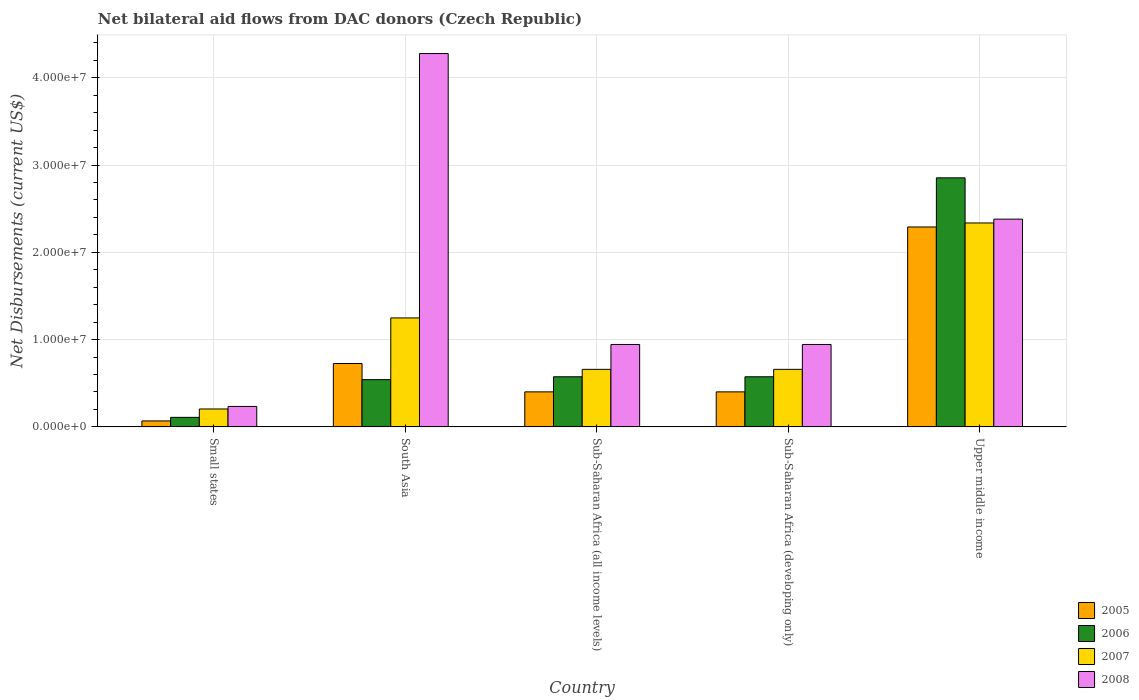How many bars are there on the 4th tick from the left?
Your answer should be compact. 4. How many bars are there on the 1st tick from the right?
Provide a succinct answer. 4. What is the label of the 4th group of bars from the left?
Keep it short and to the point. Sub-Saharan Africa (developing only). What is the net bilateral aid flows in 2006 in Sub-Saharan Africa (all income levels)?
Your answer should be very brief. 5.74e+06. Across all countries, what is the maximum net bilateral aid flows in 2006?
Make the answer very short. 2.85e+07. Across all countries, what is the minimum net bilateral aid flows in 2008?
Provide a short and direct response. 2.34e+06. In which country was the net bilateral aid flows in 2006 maximum?
Make the answer very short. Upper middle income. In which country was the net bilateral aid flows in 2006 minimum?
Your answer should be compact. Small states. What is the total net bilateral aid flows in 2008 in the graph?
Give a very brief answer. 8.78e+07. What is the difference between the net bilateral aid flows in 2007 in South Asia and that in Upper middle income?
Provide a succinct answer. -1.09e+07. What is the difference between the net bilateral aid flows in 2005 in Sub-Saharan Africa (all income levels) and the net bilateral aid flows in 2007 in Small states?
Provide a succinct answer. 1.96e+06. What is the average net bilateral aid flows in 2007 per country?
Offer a very short reply. 1.02e+07. What is the difference between the net bilateral aid flows of/in 2006 and net bilateral aid flows of/in 2008 in South Asia?
Provide a succinct answer. -3.74e+07. In how many countries, is the net bilateral aid flows in 2008 greater than 2000000 US$?
Your answer should be compact. 5. What is the ratio of the net bilateral aid flows in 2006 in Small states to that in Sub-Saharan Africa (developing only)?
Your answer should be compact. 0.19. Is the net bilateral aid flows in 2006 in Small states less than that in Upper middle income?
Offer a terse response. Yes. What is the difference between the highest and the second highest net bilateral aid flows in 2005?
Your answer should be compact. 1.89e+07. What is the difference between the highest and the lowest net bilateral aid flows in 2007?
Keep it short and to the point. 2.13e+07. In how many countries, is the net bilateral aid flows in 2007 greater than the average net bilateral aid flows in 2007 taken over all countries?
Offer a terse response. 2. What does the 4th bar from the left in Small states represents?
Your response must be concise. 2008. Is it the case that in every country, the sum of the net bilateral aid flows in 2006 and net bilateral aid flows in 2005 is greater than the net bilateral aid flows in 2007?
Ensure brevity in your answer.  No. Are all the bars in the graph horizontal?
Your answer should be compact. No. How many countries are there in the graph?
Your response must be concise. 5. Are the values on the major ticks of Y-axis written in scientific E-notation?
Your response must be concise. Yes. Does the graph contain grids?
Provide a short and direct response. Yes. Where does the legend appear in the graph?
Make the answer very short. Bottom right. What is the title of the graph?
Give a very brief answer. Net bilateral aid flows from DAC donors (Czech Republic). Does "1970" appear as one of the legend labels in the graph?
Offer a very short reply. No. What is the label or title of the Y-axis?
Provide a short and direct response. Net Disbursements (current US$). What is the Net Disbursements (current US$) of 2005 in Small states?
Keep it short and to the point. 6.80e+05. What is the Net Disbursements (current US$) of 2006 in Small states?
Provide a succinct answer. 1.09e+06. What is the Net Disbursements (current US$) in 2007 in Small states?
Keep it short and to the point. 2.05e+06. What is the Net Disbursements (current US$) of 2008 in Small states?
Provide a short and direct response. 2.34e+06. What is the Net Disbursements (current US$) of 2005 in South Asia?
Keep it short and to the point. 7.26e+06. What is the Net Disbursements (current US$) of 2006 in South Asia?
Keep it short and to the point. 5.41e+06. What is the Net Disbursements (current US$) in 2007 in South Asia?
Your answer should be very brief. 1.25e+07. What is the Net Disbursements (current US$) in 2008 in South Asia?
Your answer should be very brief. 4.28e+07. What is the Net Disbursements (current US$) of 2005 in Sub-Saharan Africa (all income levels)?
Provide a succinct answer. 4.01e+06. What is the Net Disbursements (current US$) in 2006 in Sub-Saharan Africa (all income levels)?
Make the answer very short. 5.74e+06. What is the Net Disbursements (current US$) of 2007 in Sub-Saharan Africa (all income levels)?
Your response must be concise. 6.59e+06. What is the Net Disbursements (current US$) in 2008 in Sub-Saharan Africa (all income levels)?
Your answer should be very brief. 9.44e+06. What is the Net Disbursements (current US$) of 2005 in Sub-Saharan Africa (developing only)?
Give a very brief answer. 4.01e+06. What is the Net Disbursements (current US$) in 2006 in Sub-Saharan Africa (developing only)?
Make the answer very short. 5.74e+06. What is the Net Disbursements (current US$) in 2007 in Sub-Saharan Africa (developing only)?
Provide a short and direct response. 6.59e+06. What is the Net Disbursements (current US$) in 2008 in Sub-Saharan Africa (developing only)?
Your answer should be compact. 9.44e+06. What is the Net Disbursements (current US$) in 2005 in Upper middle income?
Offer a terse response. 2.29e+07. What is the Net Disbursements (current US$) of 2006 in Upper middle income?
Keep it short and to the point. 2.85e+07. What is the Net Disbursements (current US$) in 2007 in Upper middle income?
Your answer should be very brief. 2.34e+07. What is the Net Disbursements (current US$) in 2008 in Upper middle income?
Your response must be concise. 2.38e+07. Across all countries, what is the maximum Net Disbursements (current US$) of 2005?
Offer a very short reply. 2.29e+07. Across all countries, what is the maximum Net Disbursements (current US$) of 2006?
Your response must be concise. 2.85e+07. Across all countries, what is the maximum Net Disbursements (current US$) of 2007?
Make the answer very short. 2.34e+07. Across all countries, what is the maximum Net Disbursements (current US$) of 2008?
Give a very brief answer. 4.28e+07. Across all countries, what is the minimum Net Disbursements (current US$) of 2005?
Provide a succinct answer. 6.80e+05. Across all countries, what is the minimum Net Disbursements (current US$) in 2006?
Offer a terse response. 1.09e+06. Across all countries, what is the minimum Net Disbursements (current US$) in 2007?
Ensure brevity in your answer.  2.05e+06. Across all countries, what is the minimum Net Disbursements (current US$) of 2008?
Your response must be concise. 2.34e+06. What is the total Net Disbursements (current US$) in 2005 in the graph?
Give a very brief answer. 3.89e+07. What is the total Net Disbursements (current US$) in 2006 in the graph?
Give a very brief answer. 4.65e+07. What is the total Net Disbursements (current US$) of 2007 in the graph?
Make the answer very short. 5.11e+07. What is the total Net Disbursements (current US$) of 2008 in the graph?
Offer a very short reply. 8.78e+07. What is the difference between the Net Disbursements (current US$) in 2005 in Small states and that in South Asia?
Offer a terse response. -6.58e+06. What is the difference between the Net Disbursements (current US$) of 2006 in Small states and that in South Asia?
Offer a terse response. -4.32e+06. What is the difference between the Net Disbursements (current US$) in 2007 in Small states and that in South Asia?
Your answer should be compact. -1.04e+07. What is the difference between the Net Disbursements (current US$) in 2008 in Small states and that in South Asia?
Offer a very short reply. -4.04e+07. What is the difference between the Net Disbursements (current US$) of 2005 in Small states and that in Sub-Saharan Africa (all income levels)?
Your answer should be very brief. -3.33e+06. What is the difference between the Net Disbursements (current US$) of 2006 in Small states and that in Sub-Saharan Africa (all income levels)?
Provide a short and direct response. -4.65e+06. What is the difference between the Net Disbursements (current US$) of 2007 in Small states and that in Sub-Saharan Africa (all income levels)?
Your answer should be very brief. -4.54e+06. What is the difference between the Net Disbursements (current US$) of 2008 in Small states and that in Sub-Saharan Africa (all income levels)?
Your response must be concise. -7.10e+06. What is the difference between the Net Disbursements (current US$) in 2005 in Small states and that in Sub-Saharan Africa (developing only)?
Give a very brief answer. -3.33e+06. What is the difference between the Net Disbursements (current US$) in 2006 in Small states and that in Sub-Saharan Africa (developing only)?
Make the answer very short. -4.65e+06. What is the difference between the Net Disbursements (current US$) in 2007 in Small states and that in Sub-Saharan Africa (developing only)?
Provide a succinct answer. -4.54e+06. What is the difference between the Net Disbursements (current US$) in 2008 in Small states and that in Sub-Saharan Africa (developing only)?
Make the answer very short. -7.10e+06. What is the difference between the Net Disbursements (current US$) in 2005 in Small states and that in Upper middle income?
Provide a succinct answer. -2.22e+07. What is the difference between the Net Disbursements (current US$) in 2006 in Small states and that in Upper middle income?
Offer a very short reply. -2.74e+07. What is the difference between the Net Disbursements (current US$) in 2007 in Small states and that in Upper middle income?
Make the answer very short. -2.13e+07. What is the difference between the Net Disbursements (current US$) in 2008 in Small states and that in Upper middle income?
Keep it short and to the point. -2.15e+07. What is the difference between the Net Disbursements (current US$) in 2005 in South Asia and that in Sub-Saharan Africa (all income levels)?
Your response must be concise. 3.25e+06. What is the difference between the Net Disbursements (current US$) of 2006 in South Asia and that in Sub-Saharan Africa (all income levels)?
Keep it short and to the point. -3.30e+05. What is the difference between the Net Disbursements (current US$) in 2007 in South Asia and that in Sub-Saharan Africa (all income levels)?
Give a very brief answer. 5.89e+06. What is the difference between the Net Disbursements (current US$) of 2008 in South Asia and that in Sub-Saharan Africa (all income levels)?
Offer a very short reply. 3.33e+07. What is the difference between the Net Disbursements (current US$) in 2005 in South Asia and that in Sub-Saharan Africa (developing only)?
Provide a succinct answer. 3.25e+06. What is the difference between the Net Disbursements (current US$) in 2006 in South Asia and that in Sub-Saharan Africa (developing only)?
Your response must be concise. -3.30e+05. What is the difference between the Net Disbursements (current US$) in 2007 in South Asia and that in Sub-Saharan Africa (developing only)?
Offer a terse response. 5.89e+06. What is the difference between the Net Disbursements (current US$) of 2008 in South Asia and that in Sub-Saharan Africa (developing only)?
Keep it short and to the point. 3.33e+07. What is the difference between the Net Disbursements (current US$) in 2005 in South Asia and that in Upper middle income?
Make the answer very short. -1.56e+07. What is the difference between the Net Disbursements (current US$) in 2006 in South Asia and that in Upper middle income?
Offer a very short reply. -2.31e+07. What is the difference between the Net Disbursements (current US$) of 2007 in South Asia and that in Upper middle income?
Offer a terse response. -1.09e+07. What is the difference between the Net Disbursements (current US$) of 2008 in South Asia and that in Upper middle income?
Keep it short and to the point. 1.90e+07. What is the difference between the Net Disbursements (current US$) of 2005 in Sub-Saharan Africa (all income levels) and that in Sub-Saharan Africa (developing only)?
Your answer should be very brief. 0. What is the difference between the Net Disbursements (current US$) in 2007 in Sub-Saharan Africa (all income levels) and that in Sub-Saharan Africa (developing only)?
Make the answer very short. 0. What is the difference between the Net Disbursements (current US$) in 2008 in Sub-Saharan Africa (all income levels) and that in Sub-Saharan Africa (developing only)?
Offer a very short reply. 0. What is the difference between the Net Disbursements (current US$) of 2005 in Sub-Saharan Africa (all income levels) and that in Upper middle income?
Give a very brief answer. -1.89e+07. What is the difference between the Net Disbursements (current US$) in 2006 in Sub-Saharan Africa (all income levels) and that in Upper middle income?
Give a very brief answer. -2.28e+07. What is the difference between the Net Disbursements (current US$) of 2007 in Sub-Saharan Africa (all income levels) and that in Upper middle income?
Give a very brief answer. -1.68e+07. What is the difference between the Net Disbursements (current US$) in 2008 in Sub-Saharan Africa (all income levels) and that in Upper middle income?
Make the answer very short. -1.44e+07. What is the difference between the Net Disbursements (current US$) in 2005 in Sub-Saharan Africa (developing only) and that in Upper middle income?
Provide a succinct answer. -1.89e+07. What is the difference between the Net Disbursements (current US$) of 2006 in Sub-Saharan Africa (developing only) and that in Upper middle income?
Ensure brevity in your answer.  -2.28e+07. What is the difference between the Net Disbursements (current US$) of 2007 in Sub-Saharan Africa (developing only) and that in Upper middle income?
Your response must be concise. -1.68e+07. What is the difference between the Net Disbursements (current US$) of 2008 in Sub-Saharan Africa (developing only) and that in Upper middle income?
Keep it short and to the point. -1.44e+07. What is the difference between the Net Disbursements (current US$) of 2005 in Small states and the Net Disbursements (current US$) of 2006 in South Asia?
Your response must be concise. -4.73e+06. What is the difference between the Net Disbursements (current US$) of 2005 in Small states and the Net Disbursements (current US$) of 2007 in South Asia?
Offer a very short reply. -1.18e+07. What is the difference between the Net Disbursements (current US$) of 2005 in Small states and the Net Disbursements (current US$) of 2008 in South Asia?
Make the answer very short. -4.21e+07. What is the difference between the Net Disbursements (current US$) in 2006 in Small states and the Net Disbursements (current US$) in 2007 in South Asia?
Ensure brevity in your answer.  -1.14e+07. What is the difference between the Net Disbursements (current US$) of 2006 in Small states and the Net Disbursements (current US$) of 2008 in South Asia?
Your answer should be compact. -4.17e+07. What is the difference between the Net Disbursements (current US$) of 2007 in Small states and the Net Disbursements (current US$) of 2008 in South Asia?
Your response must be concise. -4.07e+07. What is the difference between the Net Disbursements (current US$) in 2005 in Small states and the Net Disbursements (current US$) in 2006 in Sub-Saharan Africa (all income levels)?
Offer a terse response. -5.06e+06. What is the difference between the Net Disbursements (current US$) in 2005 in Small states and the Net Disbursements (current US$) in 2007 in Sub-Saharan Africa (all income levels)?
Give a very brief answer. -5.91e+06. What is the difference between the Net Disbursements (current US$) in 2005 in Small states and the Net Disbursements (current US$) in 2008 in Sub-Saharan Africa (all income levels)?
Provide a short and direct response. -8.76e+06. What is the difference between the Net Disbursements (current US$) in 2006 in Small states and the Net Disbursements (current US$) in 2007 in Sub-Saharan Africa (all income levels)?
Provide a succinct answer. -5.50e+06. What is the difference between the Net Disbursements (current US$) in 2006 in Small states and the Net Disbursements (current US$) in 2008 in Sub-Saharan Africa (all income levels)?
Your answer should be compact. -8.35e+06. What is the difference between the Net Disbursements (current US$) of 2007 in Small states and the Net Disbursements (current US$) of 2008 in Sub-Saharan Africa (all income levels)?
Give a very brief answer. -7.39e+06. What is the difference between the Net Disbursements (current US$) of 2005 in Small states and the Net Disbursements (current US$) of 2006 in Sub-Saharan Africa (developing only)?
Provide a short and direct response. -5.06e+06. What is the difference between the Net Disbursements (current US$) of 2005 in Small states and the Net Disbursements (current US$) of 2007 in Sub-Saharan Africa (developing only)?
Your answer should be compact. -5.91e+06. What is the difference between the Net Disbursements (current US$) of 2005 in Small states and the Net Disbursements (current US$) of 2008 in Sub-Saharan Africa (developing only)?
Make the answer very short. -8.76e+06. What is the difference between the Net Disbursements (current US$) in 2006 in Small states and the Net Disbursements (current US$) in 2007 in Sub-Saharan Africa (developing only)?
Your answer should be compact. -5.50e+06. What is the difference between the Net Disbursements (current US$) of 2006 in Small states and the Net Disbursements (current US$) of 2008 in Sub-Saharan Africa (developing only)?
Your answer should be compact. -8.35e+06. What is the difference between the Net Disbursements (current US$) of 2007 in Small states and the Net Disbursements (current US$) of 2008 in Sub-Saharan Africa (developing only)?
Ensure brevity in your answer.  -7.39e+06. What is the difference between the Net Disbursements (current US$) in 2005 in Small states and the Net Disbursements (current US$) in 2006 in Upper middle income?
Your answer should be compact. -2.78e+07. What is the difference between the Net Disbursements (current US$) in 2005 in Small states and the Net Disbursements (current US$) in 2007 in Upper middle income?
Give a very brief answer. -2.27e+07. What is the difference between the Net Disbursements (current US$) of 2005 in Small states and the Net Disbursements (current US$) of 2008 in Upper middle income?
Provide a succinct answer. -2.31e+07. What is the difference between the Net Disbursements (current US$) of 2006 in Small states and the Net Disbursements (current US$) of 2007 in Upper middle income?
Your answer should be very brief. -2.23e+07. What is the difference between the Net Disbursements (current US$) of 2006 in Small states and the Net Disbursements (current US$) of 2008 in Upper middle income?
Offer a very short reply. -2.27e+07. What is the difference between the Net Disbursements (current US$) of 2007 in Small states and the Net Disbursements (current US$) of 2008 in Upper middle income?
Ensure brevity in your answer.  -2.18e+07. What is the difference between the Net Disbursements (current US$) of 2005 in South Asia and the Net Disbursements (current US$) of 2006 in Sub-Saharan Africa (all income levels)?
Offer a terse response. 1.52e+06. What is the difference between the Net Disbursements (current US$) in 2005 in South Asia and the Net Disbursements (current US$) in 2007 in Sub-Saharan Africa (all income levels)?
Give a very brief answer. 6.70e+05. What is the difference between the Net Disbursements (current US$) in 2005 in South Asia and the Net Disbursements (current US$) in 2008 in Sub-Saharan Africa (all income levels)?
Make the answer very short. -2.18e+06. What is the difference between the Net Disbursements (current US$) of 2006 in South Asia and the Net Disbursements (current US$) of 2007 in Sub-Saharan Africa (all income levels)?
Your answer should be very brief. -1.18e+06. What is the difference between the Net Disbursements (current US$) in 2006 in South Asia and the Net Disbursements (current US$) in 2008 in Sub-Saharan Africa (all income levels)?
Provide a succinct answer. -4.03e+06. What is the difference between the Net Disbursements (current US$) in 2007 in South Asia and the Net Disbursements (current US$) in 2008 in Sub-Saharan Africa (all income levels)?
Keep it short and to the point. 3.04e+06. What is the difference between the Net Disbursements (current US$) of 2005 in South Asia and the Net Disbursements (current US$) of 2006 in Sub-Saharan Africa (developing only)?
Keep it short and to the point. 1.52e+06. What is the difference between the Net Disbursements (current US$) of 2005 in South Asia and the Net Disbursements (current US$) of 2007 in Sub-Saharan Africa (developing only)?
Ensure brevity in your answer.  6.70e+05. What is the difference between the Net Disbursements (current US$) in 2005 in South Asia and the Net Disbursements (current US$) in 2008 in Sub-Saharan Africa (developing only)?
Offer a terse response. -2.18e+06. What is the difference between the Net Disbursements (current US$) of 2006 in South Asia and the Net Disbursements (current US$) of 2007 in Sub-Saharan Africa (developing only)?
Provide a short and direct response. -1.18e+06. What is the difference between the Net Disbursements (current US$) of 2006 in South Asia and the Net Disbursements (current US$) of 2008 in Sub-Saharan Africa (developing only)?
Your answer should be compact. -4.03e+06. What is the difference between the Net Disbursements (current US$) in 2007 in South Asia and the Net Disbursements (current US$) in 2008 in Sub-Saharan Africa (developing only)?
Offer a very short reply. 3.04e+06. What is the difference between the Net Disbursements (current US$) of 2005 in South Asia and the Net Disbursements (current US$) of 2006 in Upper middle income?
Your answer should be compact. -2.13e+07. What is the difference between the Net Disbursements (current US$) in 2005 in South Asia and the Net Disbursements (current US$) in 2007 in Upper middle income?
Ensure brevity in your answer.  -1.61e+07. What is the difference between the Net Disbursements (current US$) of 2005 in South Asia and the Net Disbursements (current US$) of 2008 in Upper middle income?
Keep it short and to the point. -1.65e+07. What is the difference between the Net Disbursements (current US$) in 2006 in South Asia and the Net Disbursements (current US$) in 2007 in Upper middle income?
Provide a short and direct response. -1.80e+07. What is the difference between the Net Disbursements (current US$) of 2006 in South Asia and the Net Disbursements (current US$) of 2008 in Upper middle income?
Offer a terse response. -1.84e+07. What is the difference between the Net Disbursements (current US$) in 2007 in South Asia and the Net Disbursements (current US$) in 2008 in Upper middle income?
Your response must be concise. -1.13e+07. What is the difference between the Net Disbursements (current US$) of 2005 in Sub-Saharan Africa (all income levels) and the Net Disbursements (current US$) of 2006 in Sub-Saharan Africa (developing only)?
Ensure brevity in your answer.  -1.73e+06. What is the difference between the Net Disbursements (current US$) of 2005 in Sub-Saharan Africa (all income levels) and the Net Disbursements (current US$) of 2007 in Sub-Saharan Africa (developing only)?
Your response must be concise. -2.58e+06. What is the difference between the Net Disbursements (current US$) in 2005 in Sub-Saharan Africa (all income levels) and the Net Disbursements (current US$) in 2008 in Sub-Saharan Africa (developing only)?
Provide a short and direct response. -5.43e+06. What is the difference between the Net Disbursements (current US$) in 2006 in Sub-Saharan Africa (all income levels) and the Net Disbursements (current US$) in 2007 in Sub-Saharan Africa (developing only)?
Provide a short and direct response. -8.50e+05. What is the difference between the Net Disbursements (current US$) in 2006 in Sub-Saharan Africa (all income levels) and the Net Disbursements (current US$) in 2008 in Sub-Saharan Africa (developing only)?
Offer a very short reply. -3.70e+06. What is the difference between the Net Disbursements (current US$) of 2007 in Sub-Saharan Africa (all income levels) and the Net Disbursements (current US$) of 2008 in Sub-Saharan Africa (developing only)?
Provide a succinct answer. -2.85e+06. What is the difference between the Net Disbursements (current US$) of 2005 in Sub-Saharan Africa (all income levels) and the Net Disbursements (current US$) of 2006 in Upper middle income?
Your answer should be compact. -2.45e+07. What is the difference between the Net Disbursements (current US$) of 2005 in Sub-Saharan Africa (all income levels) and the Net Disbursements (current US$) of 2007 in Upper middle income?
Your answer should be very brief. -1.94e+07. What is the difference between the Net Disbursements (current US$) of 2005 in Sub-Saharan Africa (all income levels) and the Net Disbursements (current US$) of 2008 in Upper middle income?
Offer a terse response. -1.98e+07. What is the difference between the Net Disbursements (current US$) of 2006 in Sub-Saharan Africa (all income levels) and the Net Disbursements (current US$) of 2007 in Upper middle income?
Ensure brevity in your answer.  -1.76e+07. What is the difference between the Net Disbursements (current US$) in 2006 in Sub-Saharan Africa (all income levels) and the Net Disbursements (current US$) in 2008 in Upper middle income?
Keep it short and to the point. -1.81e+07. What is the difference between the Net Disbursements (current US$) in 2007 in Sub-Saharan Africa (all income levels) and the Net Disbursements (current US$) in 2008 in Upper middle income?
Ensure brevity in your answer.  -1.72e+07. What is the difference between the Net Disbursements (current US$) in 2005 in Sub-Saharan Africa (developing only) and the Net Disbursements (current US$) in 2006 in Upper middle income?
Provide a short and direct response. -2.45e+07. What is the difference between the Net Disbursements (current US$) of 2005 in Sub-Saharan Africa (developing only) and the Net Disbursements (current US$) of 2007 in Upper middle income?
Offer a terse response. -1.94e+07. What is the difference between the Net Disbursements (current US$) in 2005 in Sub-Saharan Africa (developing only) and the Net Disbursements (current US$) in 2008 in Upper middle income?
Provide a succinct answer. -1.98e+07. What is the difference between the Net Disbursements (current US$) of 2006 in Sub-Saharan Africa (developing only) and the Net Disbursements (current US$) of 2007 in Upper middle income?
Provide a succinct answer. -1.76e+07. What is the difference between the Net Disbursements (current US$) of 2006 in Sub-Saharan Africa (developing only) and the Net Disbursements (current US$) of 2008 in Upper middle income?
Provide a short and direct response. -1.81e+07. What is the difference between the Net Disbursements (current US$) in 2007 in Sub-Saharan Africa (developing only) and the Net Disbursements (current US$) in 2008 in Upper middle income?
Provide a short and direct response. -1.72e+07. What is the average Net Disbursements (current US$) in 2005 per country?
Your response must be concise. 7.77e+06. What is the average Net Disbursements (current US$) in 2006 per country?
Give a very brief answer. 9.30e+06. What is the average Net Disbursements (current US$) in 2007 per country?
Keep it short and to the point. 1.02e+07. What is the average Net Disbursements (current US$) in 2008 per country?
Provide a short and direct response. 1.76e+07. What is the difference between the Net Disbursements (current US$) of 2005 and Net Disbursements (current US$) of 2006 in Small states?
Make the answer very short. -4.10e+05. What is the difference between the Net Disbursements (current US$) of 2005 and Net Disbursements (current US$) of 2007 in Small states?
Offer a terse response. -1.37e+06. What is the difference between the Net Disbursements (current US$) of 2005 and Net Disbursements (current US$) of 2008 in Small states?
Your answer should be very brief. -1.66e+06. What is the difference between the Net Disbursements (current US$) in 2006 and Net Disbursements (current US$) in 2007 in Small states?
Your response must be concise. -9.60e+05. What is the difference between the Net Disbursements (current US$) in 2006 and Net Disbursements (current US$) in 2008 in Small states?
Provide a short and direct response. -1.25e+06. What is the difference between the Net Disbursements (current US$) of 2007 and Net Disbursements (current US$) of 2008 in Small states?
Your answer should be very brief. -2.90e+05. What is the difference between the Net Disbursements (current US$) of 2005 and Net Disbursements (current US$) of 2006 in South Asia?
Ensure brevity in your answer.  1.85e+06. What is the difference between the Net Disbursements (current US$) in 2005 and Net Disbursements (current US$) in 2007 in South Asia?
Your response must be concise. -5.22e+06. What is the difference between the Net Disbursements (current US$) in 2005 and Net Disbursements (current US$) in 2008 in South Asia?
Keep it short and to the point. -3.55e+07. What is the difference between the Net Disbursements (current US$) of 2006 and Net Disbursements (current US$) of 2007 in South Asia?
Make the answer very short. -7.07e+06. What is the difference between the Net Disbursements (current US$) in 2006 and Net Disbursements (current US$) in 2008 in South Asia?
Your response must be concise. -3.74e+07. What is the difference between the Net Disbursements (current US$) of 2007 and Net Disbursements (current US$) of 2008 in South Asia?
Your response must be concise. -3.03e+07. What is the difference between the Net Disbursements (current US$) in 2005 and Net Disbursements (current US$) in 2006 in Sub-Saharan Africa (all income levels)?
Offer a terse response. -1.73e+06. What is the difference between the Net Disbursements (current US$) of 2005 and Net Disbursements (current US$) of 2007 in Sub-Saharan Africa (all income levels)?
Make the answer very short. -2.58e+06. What is the difference between the Net Disbursements (current US$) in 2005 and Net Disbursements (current US$) in 2008 in Sub-Saharan Africa (all income levels)?
Keep it short and to the point. -5.43e+06. What is the difference between the Net Disbursements (current US$) in 2006 and Net Disbursements (current US$) in 2007 in Sub-Saharan Africa (all income levels)?
Offer a terse response. -8.50e+05. What is the difference between the Net Disbursements (current US$) in 2006 and Net Disbursements (current US$) in 2008 in Sub-Saharan Africa (all income levels)?
Provide a succinct answer. -3.70e+06. What is the difference between the Net Disbursements (current US$) in 2007 and Net Disbursements (current US$) in 2008 in Sub-Saharan Africa (all income levels)?
Provide a short and direct response. -2.85e+06. What is the difference between the Net Disbursements (current US$) of 2005 and Net Disbursements (current US$) of 2006 in Sub-Saharan Africa (developing only)?
Keep it short and to the point. -1.73e+06. What is the difference between the Net Disbursements (current US$) of 2005 and Net Disbursements (current US$) of 2007 in Sub-Saharan Africa (developing only)?
Provide a short and direct response. -2.58e+06. What is the difference between the Net Disbursements (current US$) of 2005 and Net Disbursements (current US$) of 2008 in Sub-Saharan Africa (developing only)?
Provide a succinct answer. -5.43e+06. What is the difference between the Net Disbursements (current US$) in 2006 and Net Disbursements (current US$) in 2007 in Sub-Saharan Africa (developing only)?
Keep it short and to the point. -8.50e+05. What is the difference between the Net Disbursements (current US$) in 2006 and Net Disbursements (current US$) in 2008 in Sub-Saharan Africa (developing only)?
Provide a succinct answer. -3.70e+06. What is the difference between the Net Disbursements (current US$) of 2007 and Net Disbursements (current US$) of 2008 in Sub-Saharan Africa (developing only)?
Provide a short and direct response. -2.85e+06. What is the difference between the Net Disbursements (current US$) in 2005 and Net Disbursements (current US$) in 2006 in Upper middle income?
Keep it short and to the point. -5.63e+06. What is the difference between the Net Disbursements (current US$) of 2005 and Net Disbursements (current US$) of 2007 in Upper middle income?
Provide a succinct answer. -4.60e+05. What is the difference between the Net Disbursements (current US$) of 2005 and Net Disbursements (current US$) of 2008 in Upper middle income?
Give a very brief answer. -9.00e+05. What is the difference between the Net Disbursements (current US$) in 2006 and Net Disbursements (current US$) in 2007 in Upper middle income?
Your answer should be very brief. 5.17e+06. What is the difference between the Net Disbursements (current US$) in 2006 and Net Disbursements (current US$) in 2008 in Upper middle income?
Provide a succinct answer. 4.73e+06. What is the difference between the Net Disbursements (current US$) in 2007 and Net Disbursements (current US$) in 2008 in Upper middle income?
Provide a short and direct response. -4.40e+05. What is the ratio of the Net Disbursements (current US$) in 2005 in Small states to that in South Asia?
Make the answer very short. 0.09. What is the ratio of the Net Disbursements (current US$) in 2006 in Small states to that in South Asia?
Your answer should be very brief. 0.2. What is the ratio of the Net Disbursements (current US$) of 2007 in Small states to that in South Asia?
Make the answer very short. 0.16. What is the ratio of the Net Disbursements (current US$) in 2008 in Small states to that in South Asia?
Offer a very short reply. 0.05. What is the ratio of the Net Disbursements (current US$) in 2005 in Small states to that in Sub-Saharan Africa (all income levels)?
Make the answer very short. 0.17. What is the ratio of the Net Disbursements (current US$) in 2006 in Small states to that in Sub-Saharan Africa (all income levels)?
Offer a terse response. 0.19. What is the ratio of the Net Disbursements (current US$) in 2007 in Small states to that in Sub-Saharan Africa (all income levels)?
Provide a succinct answer. 0.31. What is the ratio of the Net Disbursements (current US$) in 2008 in Small states to that in Sub-Saharan Africa (all income levels)?
Give a very brief answer. 0.25. What is the ratio of the Net Disbursements (current US$) in 2005 in Small states to that in Sub-Saharan Africa (developing only)?
Make the answer very short. 0.17. What is the ratio of the Net Disbursements (current US$) of 2006 in Small states to that in Sub-Saharan Africa (developing only)?
Offer a terse response. 0.19. What is the ratio of the Net Disbursements (current US$) in 2007 in Small states to that in Sub-Saharan Africa (developing only)?
Your answer should be compact. 0.31. What is the ratio of the Net Disbursements (current US$) of 2008 in Small states to that in Sub-Saharan Africa (developing only)?
Give a very brief answer. 0.25. What is the ratio of the Net Disbursements (current US$) of 2005 in Small states to that in Upper middle income?
Offer a very short reply. 0.03. What is the ratio of the Net Disbursements (current US$) of 2006 in Small states to that in Upper middle income?
Your answer should be compact. 0.04. What is the ratio of the Net Disbursements (current US$) in 2007 in Small states to that in Upper middle income?
Ensure brevity in your answer.  0.09. What is the ratio of the Net Disbursements (current US$) in 2008 in Small states to that in Upper middle income?
Offer a very short reply. 0.1. What is the ratio of the Net Disbursements (current US$) in 2005 in South Asia to that in Sub-Saharan Africa (all income levels)?
Offer a very short reply. 1.81. What is the ratio of the Net Disbursements (current US$) of 2006 in South Asia to that in Sub-Saharan Africa (all income levels)?
Ensure brevity in your answer.  0.94. What is the ratio of the Net Disbursements (current US$) of 2007 in South Asia to that in Sub-Saharan Africa (all income levels)?
Give a very brief answer. 1.89. What is the ratio of the Net Disbursements (current US$) in 2008 in South Asia to that in Sub-Saharan Africa (all income levels)?
Provide a succinct answer. 4.53. What is the ratio of the Net Disbursements (current US$) in 2005 in South Asia to that in Sub-Saharan Africa (developing only)?
Provide a succinct answer. 1.81. What is the ratio of the Net Disbursements (current US$) of 2006 in South Asia to that in Sub-Saharan Africa (developing only)?
Ensure brevity in your answer.  0.94. What is the ratio of the Net Disbursements (current US$) of 2007 in South Asia to that in Sub-Saharan Africa (developing only)?
Ensure brevity in your answer.  1.89. What is the ratio of the Net Disbursements (current US$) of 2008 in South Asia to that in Sub-Saharan Africa (developing only)?
Keep it short and to the point. 4.53. What is the ratio of the Net Disbursements (current US$) of 2005 in South Asia to that in Upper middle income?
Your answer should be compact. 0.32. What is the ratio of the Net Disbursements (current US$) of 2006 in South Asia to that in Upper middle income?
Provide a short and direct response. 0.19. What is the ratio of the Net Disbursements (current US$) in 2007 in South Asia to that in Upper middle income?
Offer a very short reply. 0.53. What is the ratio of the Net Disbursements (current US$) in 2008 in South Asia to that in Upper middle income?
Provide a succinct answer. 1.8. What is the ratio of the Net Disbursements (current US$) in 2005 in Sub-Saharan Africa (all income levels) to that in Sub-Saharan Africa (developing only)?
Your answer should be very brief. 1. What is the ratio of the Net Disbursements (current US$) of 2005 in Sub-Saharan Africa (all income levels) to that in Upper middle income?
Offer a terse response. 0.18. What is the ratio of the Net Disbursements (current US$) in 2006 in Sub-Saharan Africa (all income levels) to that in Upper middle income?
Ensure brevity in your answer.  0.2. What is the ratio of the Net Disbursements (current US$) in 2007 in Sub-Saharan Africa (all income levels) to that in Upper middle income?
Ensure brevity in your answer.  0.28. What is the ratio of the Net Disbursements (current US$) in 2008 in Sub-Saharan Africa (all income levels) to that in Upper middle income?
Your response must be concise. 0.4. What is the ratio of the Net Disbursements (current US$) of 2005 in Sub-Saharan Africa (developing only) to that in Upper middle income?
Provide a short and direct response. 0.18. What is the ratio of the Net Disbursements (current US$) in 2006 in Sub-Saharan Africa (developing only) to that in Upper middle income?
Your response must be concise. 0.2. What is the ratio of the Net Disbursements (current US$) of 2007 in Sub-Saharan Africa (developing only) to that in Upper middle income?
Your answer should be compact. 0.28. What is the ratio of the Net Disbursements (current US$) of 2008 in Sub-Saharan Africa (developing only) to that in Upper middle income?
Keep it short and to the point. 0.4. What is the difference between the highest and the second highest Net Disbursements (current US$) in 2005?
Offer a very short reply. 1.56e+07. What is the difference between the highest and the second highest Net Disbursements (current US$) in 2006?
Give a very brief answer. 2.28e+07. What is the difference between the highest and the second highest Net Disbursements (current US$) of 2007?
Keep it short and to the point. 1.09e+07. What is the difference between the highest and the second highest Net Disbursements (current US$) in 2008?
Make the answer very short. 1.90e+07. What is the difference between the highest and the lowest Net Disbursements (current US$) of 2005?
Ensure brevity in your answer.  2.22e+07. What is the difference between the highest and the lowest Net Disbursements (current US$) in 2006?
Offer a terse response. 2.74e+07. What is the difference between the highest and the lowest Net Disbursements (current US$) in 2007?
Provide a short and direct response. 2.13e+07. What is the difference between the highest and the lowest Net Disbursements (current US$) in 2008?
Give a very brief answer. 4.04e+07. 